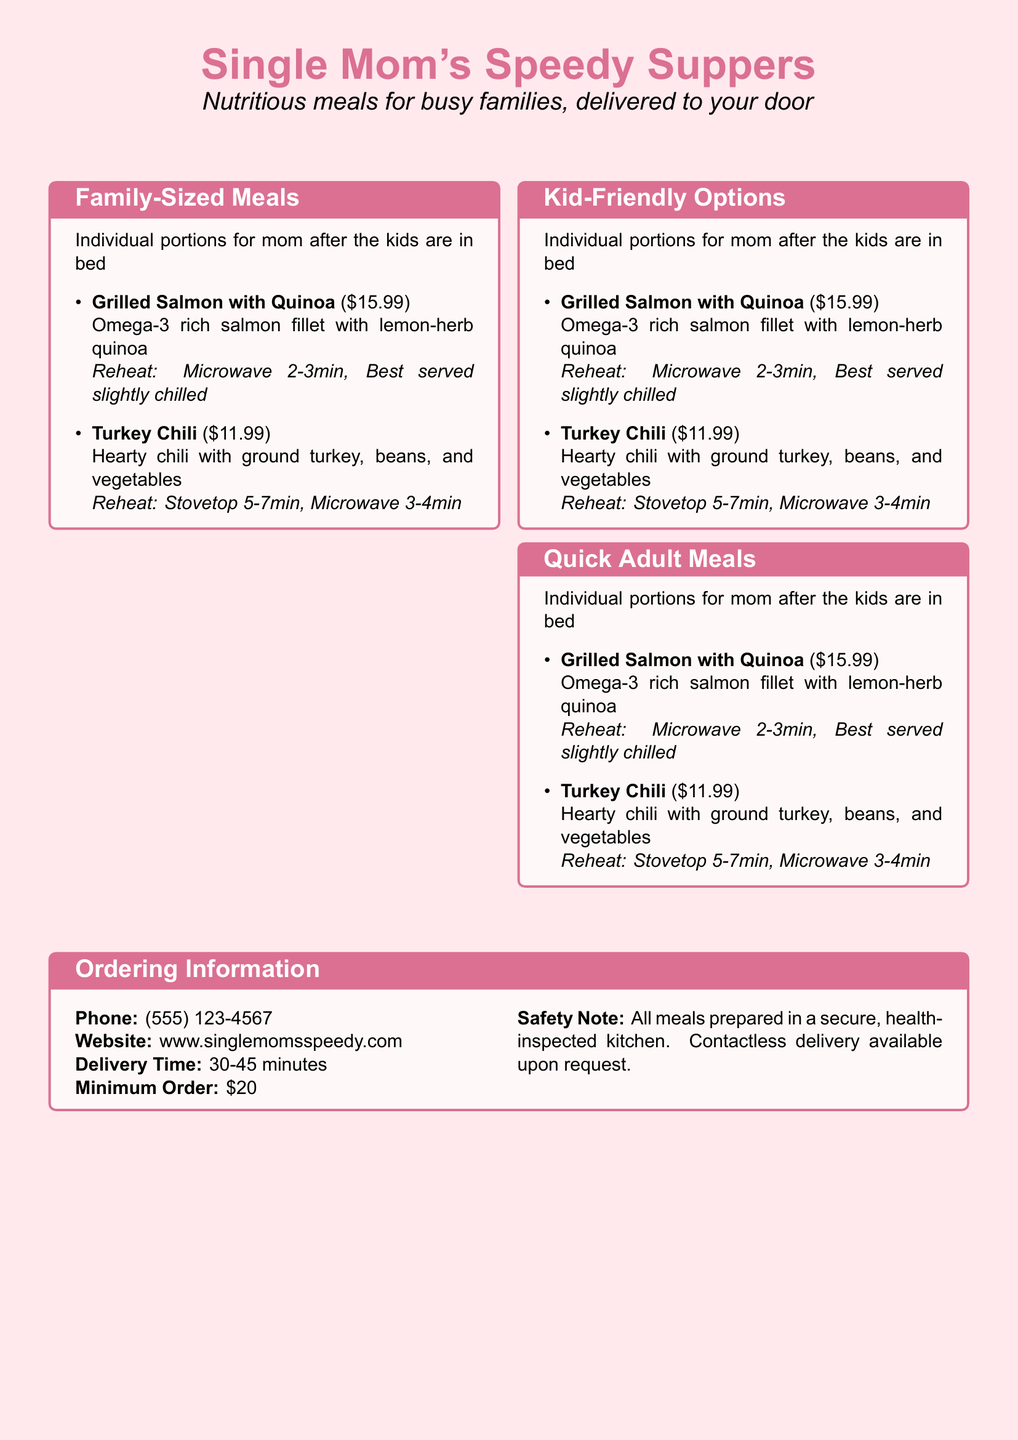what is the price of Chicken Parmesan Bake? The price of Chicken Parmesan Bake is listed in the menu under Family-Sized Meals.
Answer: $24.99 how many people does Veggie Lasagna serve? Veggie Lasagna is noted to feed 3-4 people, as indicated in the Family-Sized Meals section.
Answer: 3-4 people what is the reheat time for Mini Cheese Pizzas in the microwave? The reheat time for Mini Cheese Pizzas in the microwave is specified in the Kid-Friendly Options section.
Answer: 1-2 minutes what meal is a healthy option for moms? The document lists Grilled Salmon with Quinoa as a nutritious individual portion for moms in the Quick Adult Meals section.
Answer: Grilled Salmon with Quinoa how long does delivery typically take? The expected delivery time is mentioned in the Ordering Information box on the menu.
Answer: 30-45 minutes which meal includes vegetables? The Kid-Friendly Options section includes Chicken Nuggets & Veggies, indicating it has vegetables.
Answer: Chicken Nuggets & Veggies what is the minimum order amount? The minimum order amount is specified in the Ordering Information section of the document.
Answer: $20 how should Turkey Chili be reheated? The reheating instructions for Turkey Chili are provided in the Quick Adult Meals section.
Answer: Stovetop 5-7 minutes, Microwave 3-4 minutes 